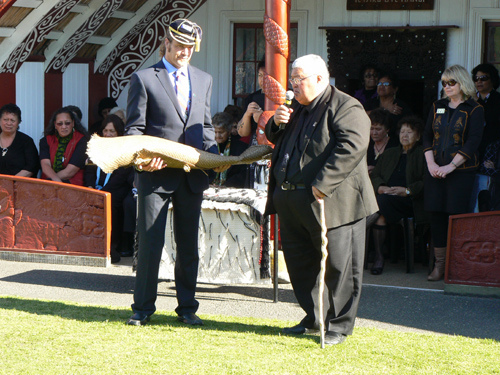<image>What is the stick for? I don't know the exact purpose of the stick. However, it can be used for walking, stability, standing, or support. What is the stick for? I don't know what the stick is for. It can be used for walking, stability, helping to stand, or as a support. 